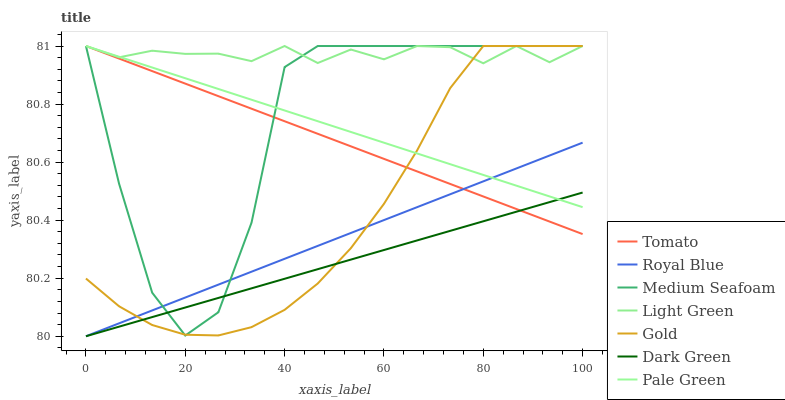Does Dark Green have the minimum area under the curve?
Answer yes or no. Yes. Does Light Green have the maximum area under the curve?
Answer yes or no. Yes. Does Gold have the minimum area under the curve?
Answer yes or no. No. Does Gold have the maximum area under the curve?
Answer yes or no. No. Is Pale Green the smoothest?
Answer yes or no. Yes. Is Medium Seafoam the roughest?
Answer yes or no. Yes. Is Gold the smoothest?
Answer yes or no. No. Is Gold the roughest?
Answer yes or no. No. Does Royal Blue have the lowest value?
Answer yes or no. Yes. Does Gold have the lowest value?
Answer yes or no. No. Does Medium Seafoam have the highest value?
Answer yes or no. Yes. Does Royal Blue have the highest value?
Answer yes or no. No. Is Dark Green less than Light Green?
Answer yes or no. Yes. Is Light Green greater than Dark Green?
Answer yes or no. Yes. Does Tomato intersect Dark Green?
Answer yes or no. Yes. Is Tomato less than Dark Green?
Answer yes or no. No. Is Tomato greater than Dark Green?
Answer yes or no. No. Does Dark Green intersect Light Green?
Answer yes or no. No. 